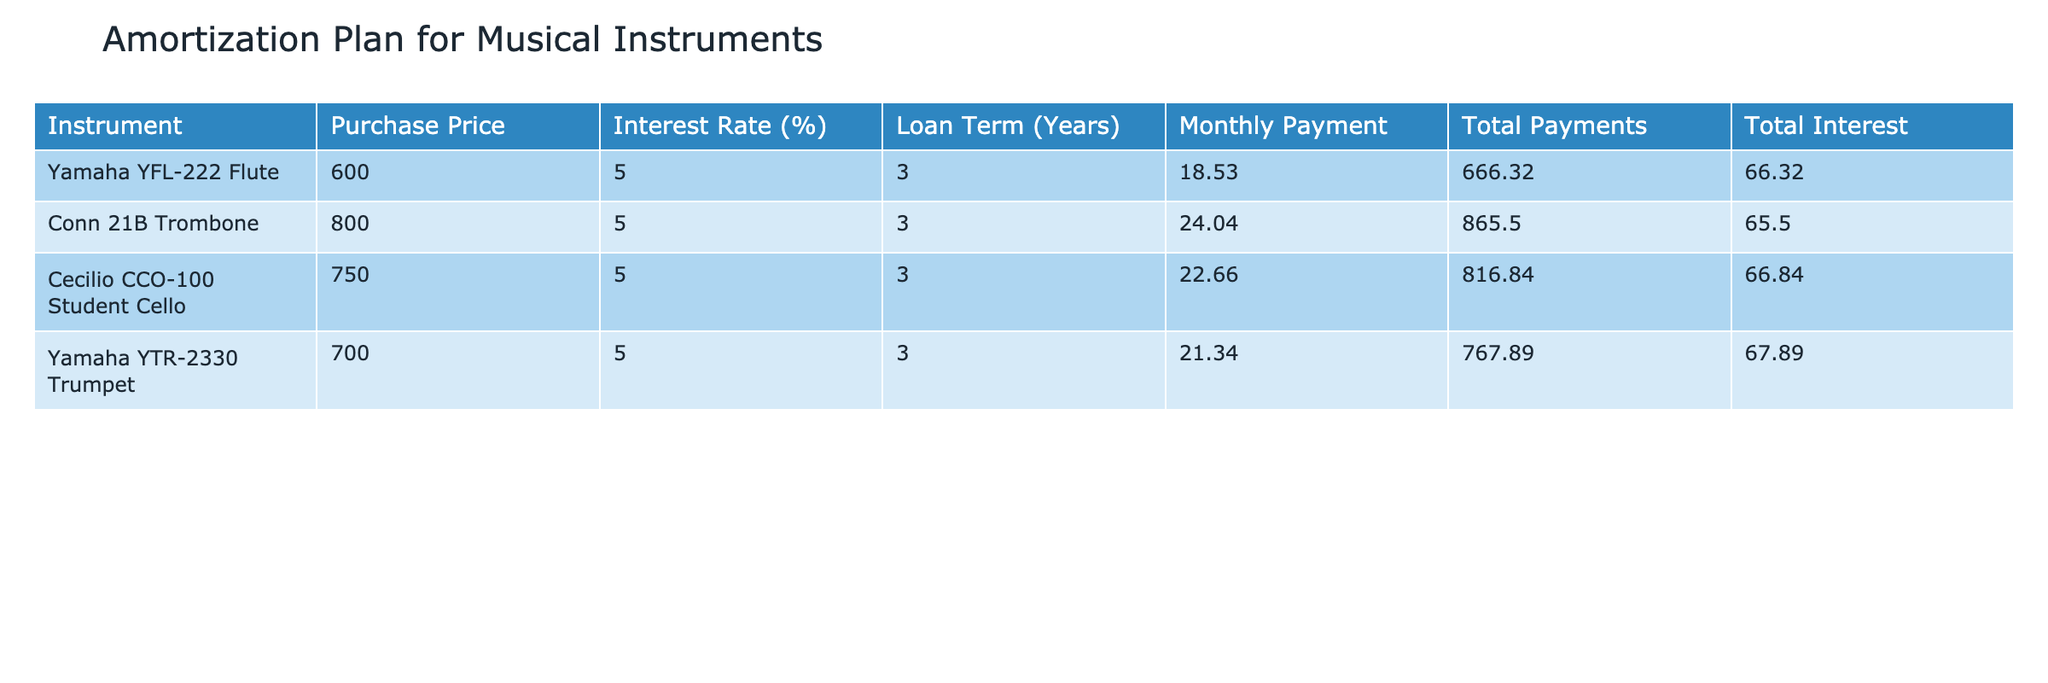What is the purchase price of the Yamaha YFL-222 Flute? According to the table, the purchase price is explicitly listed in the 'Purchase Price' column for the Yamaha YFL-222 Flute. The value indicated is 600.
Answer: 600 What is the total interest paid on the Conn 21B Trombone over the loan term? The total interest for the Conn 21B Trombone is found in the 'Total Interest' column. The value listed is 65.50.
Answer: 65.50 Which instrument has the highest total payments? To find the highest total payments, compare the 'Total Payments' column for each instrument. The Cecilio CCO-100 Student Cello has total payments of 816.84, which is the highest.
Answer: Cecilio CCO-100 Student Cello What is the average monthly payment across all instruments? To find the average monthly payment, sum up all the monthly payments: 18.53 + 24.04 + 22.66 + 21.34 = 86.57. There are four instruments, so divide by 4, resulting in an average of 21.64.
Answer: 21.64 Is the total payments for the Yamaha YTR-2330 Trumpet greater than 700? The total payments for the Yamaha YTR-2330 Trumpet are listed as 767.89 in the table, which is indeed greater than 700. Hence, the answer is yes.
Answer: Yes What is the difference in total interest between the Cecilio CCO-100 Student Cello and the Yamaha YFL-222 Flute? The total interest for the Cecilio CCO-100 Student Cello is 66.84 and for the Yamaha YFL-222 Flute is 66.32. To find the difference, calculate 66.84 - 66.32 = 0.52.
Answer: 0.52 Which instrument has the lowest purchase price? Comparing the 'Purchase Price' column, the Yamaha YFL-222 Flute at 600 is lower than the other instruments priced at 750, 800, and 700.
Answer: Yamaha YFL-222 Flute If a community choir needed to purchase all four instruments, what would be the total cost of the instruments including interest? To calculate the total cost, sum the 'Total Payments' of all instruments: 666.32 + 865.50 + 816.84 + 767.89 = 3116.55. Thus, the total cost including interest is 3116.55.
Answer: 3116.55 What percentage of the purchase price does the total interest represent for the Yamaha YFL-222 Flute? First, note the purchase price of the Yamaha YFL-222 Flute is 600 and the total interest is 66.32. Calculate the percentage as (66.32 / 600) * 100 = 11.05%.
Answer: 11.05% 